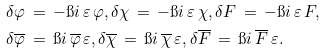<formula> <loc_0><loc_0><loc_500><loc_500>\delta \varphi \, & = \, - \i i \, \varepsilon \, \varphi , \delta \chi \, = \, - \i i \, \varepsilon \, \chi , \delta F \, = \, - \i i \, \varepsilon \, F , \\ \delta \overline { \varphi } \, & = \, \i i \, \overline { \varphi } \, \varepsilon , \delta \overline { \chi } \, = \, \i i \, \overline { \chi } \, \varepsilon , \delta \overline { F } \, = \, \i i \, \overline { F } \, \varepsilon .</formula> 